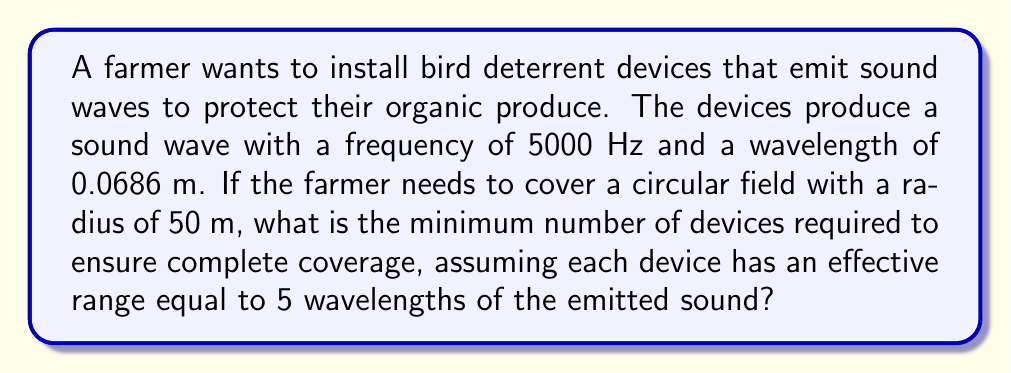Can you answer this question? Let's approach this step-by-step:

1) First, we need to calculate the effective range of each device:
   Range = 5 × wavelength
   Range = 5 × 0.0686 m = 0.343 m

2) Now, we need to determine how many of these ranges fit into the diameter of the field:
   Field diameter = 2 × radius = 2 × 50 m = 100 m

3) Number of ranges across diameter = Field diameter ÷ Range
   $$\frac{100 \text{ m}}{0.343 \text{ m}} \approx 291.545$$

4) Since we can't have a fractional number of devices, we round up to 292.

5) However, this only covers the diameter. To cover the entire circular area, we need to square this number:
   $$292^2 = 85,264$$

6) This is the theoretical minimum number of devices needed to cover the entire circular field.

[asy]
unitsize(2cm);
draw(circle((0,0),1), blue);
dot((0,0));
label("50m", (0.5,0), E);
draw((0,0)--(1,0), arrow=Arrow(TeXHead));
[/asy]

The diagram above represents the circular field with its radius.
Answer: 85,264 devices 